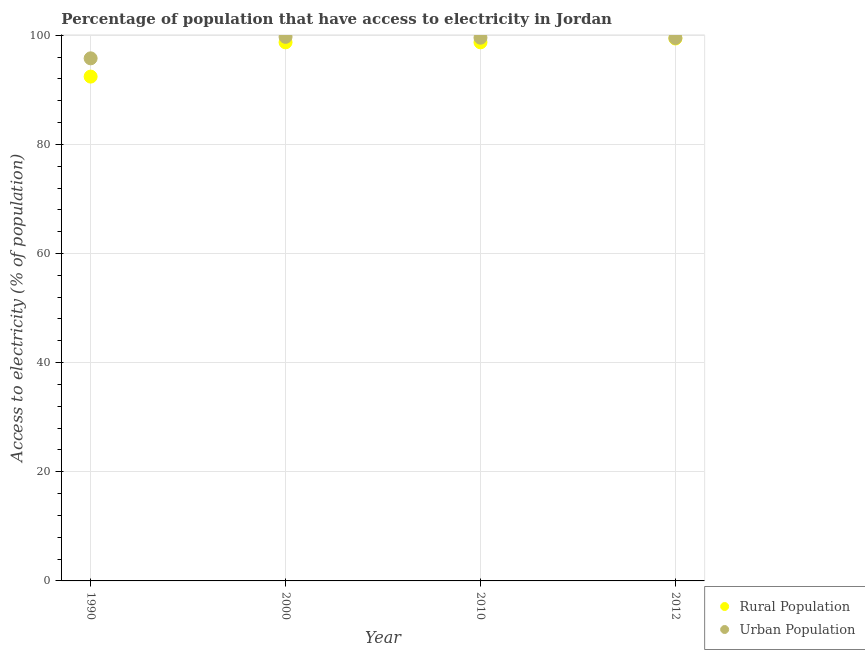Is the number of dotlines equal to the number of legend labels?
Ensure brevity in your answer.  Yes. What is the percentage of rural population having access to electricity in 2000?
Ensure brevity in your answer.  98.7. Across all years, what is the maximum percentage of rural population having access to electricity?
Provide a succinct answer. 99.4. Across all years, what is the minimum percentage of urban population having access to electricity?
Your answer should be very brief. 95.77. In which year was the percentage of urban population having access to electricity maximum?
Provide a short and direct response. 2000. In which year was the percentage of urban population having access to electricity minimum?
Provide a succinct answer. 1990. What is the total percentage of urban population having access to electricity in the graph?
Offer a terse response. 394.52. What is the difference between the percentage of urban population having access to electricity in 2000 and that in 2010?
Give a very brief answer. 0.15. What is the difference between the percentage of urban population having access to electricity in 2010 and the percentage of rural population having access to electricity in 1990?
Offer a very short reply. 7.13. What is the average percentage of rural population having access to electricity per year?
Give a very brief answer. 97.3. In the year 1990, what is the difference between the percentage of rural population having access to electricity and percentage of urban population having access to electricity?
Offer a terse response. -3.35. In how many years, is the percentage of urban population having access to electricity greater than 16 %?
Ensure brevity in your answer.  4. What is the ratio of the percentage of rural population having access to electricity in 1990 to that in 2000?
Provide a short and direct response. 0.94. Is the difference between the percentage of rural population having access to electricity in 1990 and 2000 greater than the difference between the percentage of urban population having access to electricity in 1990 and 2000?
Offer a very short reply. No. What is the difference between the highest and the second highest percentage of rural population having access to electricity?
Offer a terse response. 0.7. What is the difference between the highest and the lowest percentage of rural population having access to electricity?
Provide a short and direct response. 6.98. In how many years, is the percentage of rural population having access to electricity greater than the average percentage of rural population having access to electricity taken over all years?
Keep it short and to the point. 3. How many years are there in the graph?
Offer a terse response. 4. What is the difference between two consecutive major ticks on the Y-axis?
Provide a short and direct response. 20. Does the graph contain any zero values?
Offer a very short reply. No. What is the title of the graph?
Your response must be concise. Percentage of population that have access to electricity in Jordan. Does "Domestic Liabilities" appear as one of the legend labels in the graph?
Offer a very short reply. No. What is the label or title of the X-axis?
Your answer should be compact. Year. What is the label or title of the Y-axis?
Provide a short and direct response. Access to electricity (% of population). What is the Access to electricity (% of population) in Rural Population in 1990?
Give a very brief answer. 92.42. What is the Access to electricity (% of population) of Urban Population in 1990?
Your answer should be compact. 95.77. What is the Access to electricity (% of population) in Rural Population in 2000?
Your answer should be compact. 98.7. What is the Access to electricity (% of population) in Urban Population in 2000?
Your answer should be compact. 99.7. What is the Access to electricity (% of population) of Rural Population in 2010?
Offer a very short reply. 98.7. What is the Access to electricity (% of population) of Urban Population in 2010?
Your answer should be very brief. 99.55. What is the Access to electricity (% of population) in Rural Population in 2012?
Provide a short and direct response. 99.4. What is the Access to electricity (% of population) in Urban Population in 2012?
Keep it short and to the point. 99.5. Across all years, what is the maximum Access to electricity (% of population) in Rural Population?
Keep it short and to the point. 99.4. Across all years, what is the maximum Access to electricity (% of population) of Urban Population?
Your answer should be compact. 99.7. Across all years, what is the minimum Access to electricity (% of population) in Rural Population?
Provide a succinct answer. 92.42. Across all years, what is the minimum Access to electricity (% of population) in Urban Population?
Your answer should be very brief. 95.77. What is the total Access to electricity (% of population) of Rural Population in the graph?
Your answer should be compact. 389.22. What is the total Access to electricity (% of population) in Urban Population in the graph?
Offer a very short reply. 394.52. What is the difference between the Access to electricity (% of population) of Rural Population in 1990 and that in 2000?
Your answer should be compact. -6.28. What is the difference between the Access to electricity (% of population) of Urban Population in 1990 and that in 2000?
Make the answer very short. -3.94. What is the difference between the Access to electricity (% of population) of Rural Population in 1990 and that in 2010?
Offer a terse response. -6.28. What is the difference between the Access to electricity (% of population) of Urban Population in 1990 and that in 2010?
Your answer should be compact. -3.78. What is the difference between the Access to electricity (% of population) in Rural Population in 1990 and that in 2012?
Ensure brevity in your answer.  -6.98. What is the difference between the Access to electricity (% of population) of Urban Population in 1990 and that in 2012?
Give a very brief answer. -3.73. What is the difference between the Access to electricity (% of population) in Urban Population in 2000 and that in 2010?
Your answer should be very brief. 0.15. What is the difference between the Access to electricity (% of population) of Urban Population in 2000 and that in 2012?
Your response must be concise. 0.2. What is the difference between the Access to electricity (% of population) of Urban Population in 2010 and that in 2012?
Give a very brief answer. 0.05. What is the difference between the Access to electricity (% of population) in Rural Population in 1990 and the Access to electricity (% of population) in Urban Population in 2000?
Provide a short and direct response. -7.28. What is the difference between the Access to electricity (% of population) of Rural Population in 1990 and the Access to electricity (% of population) of Urban Population in 2010?
Make the answer very short. -7.13. What is the difference between the Access to electricity (% of population) of Rural Population in 1990 and the Access to electricity (% of population) of Urban Population in 2012?
Your response must be concise. -7.08. What is the difference between the Access to electricity (% of population) in Rural Population in 2000 and the Access to electricity (% of population) in Urban Population in 2010?
Your answer should be very brief. -0.85. What is the average Access to electricity (% of population) in Rural Population per year?
Your answer should be very brief. 97.3. What is the average Access to electricity (% of population) in Urban Population per year?
Offer a terse response. 98.63. In the year 1990, what is the difference between the Access to electricity (% of population) in Rural Population and Access to electricity (% of population) in Urban Population?
Give a very brief answer. -3.35. In the year 2000, what is the difference between the Access to electricity (% of population) in Rural Population and Access to electricity (% of population) in Urban Population?
Your answer should be compact. -1. In the year 2010, what is the difference between the Access to electricity (% of population) of Rural Population and Access to electricity (% of population) of Urban Population?
Keep it short and to the point. -0.85. In the year 2012, what is the difference between the Access to electricity (% of population) of Rural Population and Access to electricity (% of population) of Urban Population?
Your answer should be very brief. -0.1. What is the ratio of the Access to electricity (% of population) of Rural Population in 1990 to that in 2000?
Offer a very short reply. 0.94. What is the ratio of the Access to electricity (% of population) in Urban Population in 1990 to that in 2000?
Your answer should be compact. 0.96. What is the ratio of the Access to electricity (% of population) in Rural Population in 1990 to that in 2010?
Keep it short and to the point. 0.94. What is the ratio of the Access to electricity (% of population) in Urban Population in 1990 to that in 2010?
Offer a very short reply. 0.96. What is the ratio of the Access to electricity (% of population) in Rural Population in 1990 to that in 2012?
Make the answer very short. 0.93. What is the ratio of the Access to electricity (% of population) of Urban Population in 1990 to that in 2012?
Make the answer very short. 0.96. What is the ratio of the Access to electricity (% of population) in Rural Population in 2000 to that in 2010?
Your response must be concise. 1. What is the ratio of the Access to electricity (% of population) in Urban Population in 2000 to that in 2012?
Your response must be concise. 1. What is the difference between the highest and the second highest Access to electricity (% of population) in Rural Population?
Give a very brief answer. 0.7. What is the difference between the highest and the second highest Access to electricity (% of population) of Urban Population?
Your answer should be compact. 0.15. What is the difference between the highest and the lowest Access to electricity (% of population) in Rural Population?
Provide a short and direct response. 6.98. What is the difference between the highest and the lowest Access to electricity (% of population) in Urban Population?
Give a very brief answer. 3.94. 